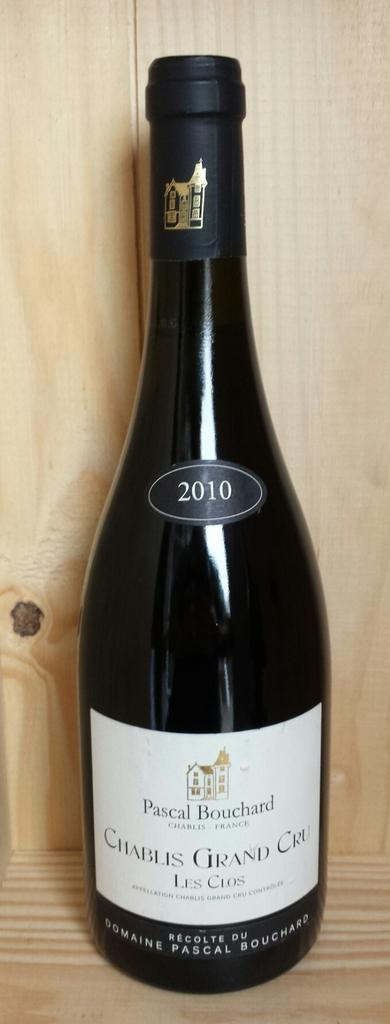<image>
Present a compact description of the photo's key features. A bottle of Pascal Bouchard wine is from 2010. 